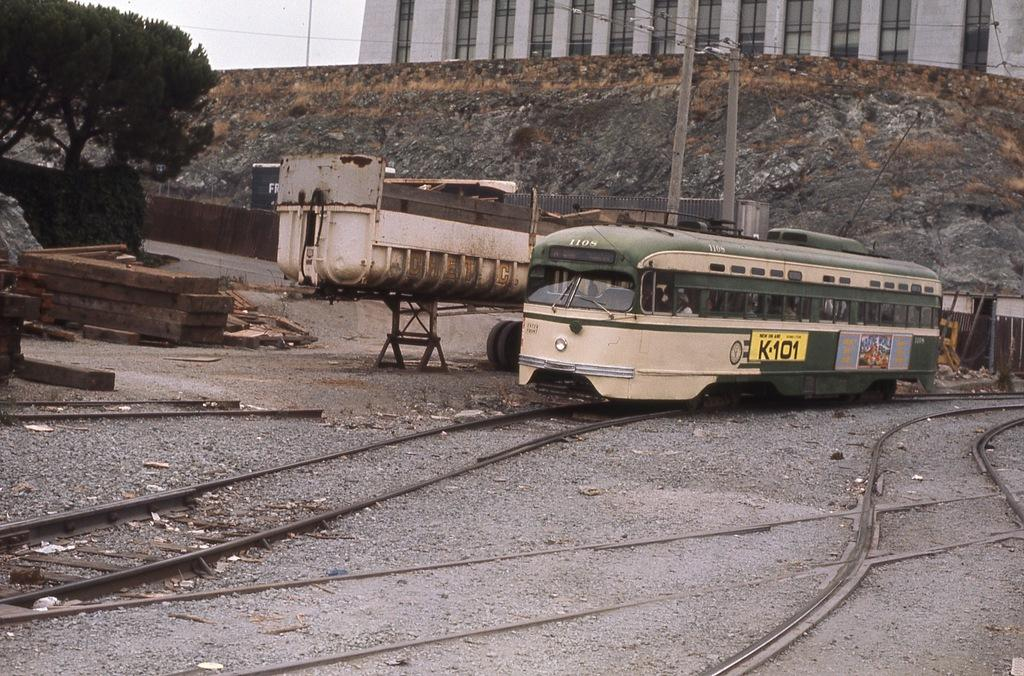<image>
Render a clear and concise summary of the photo. A train that's out of service still carries a K-101 advertisement on its side. 